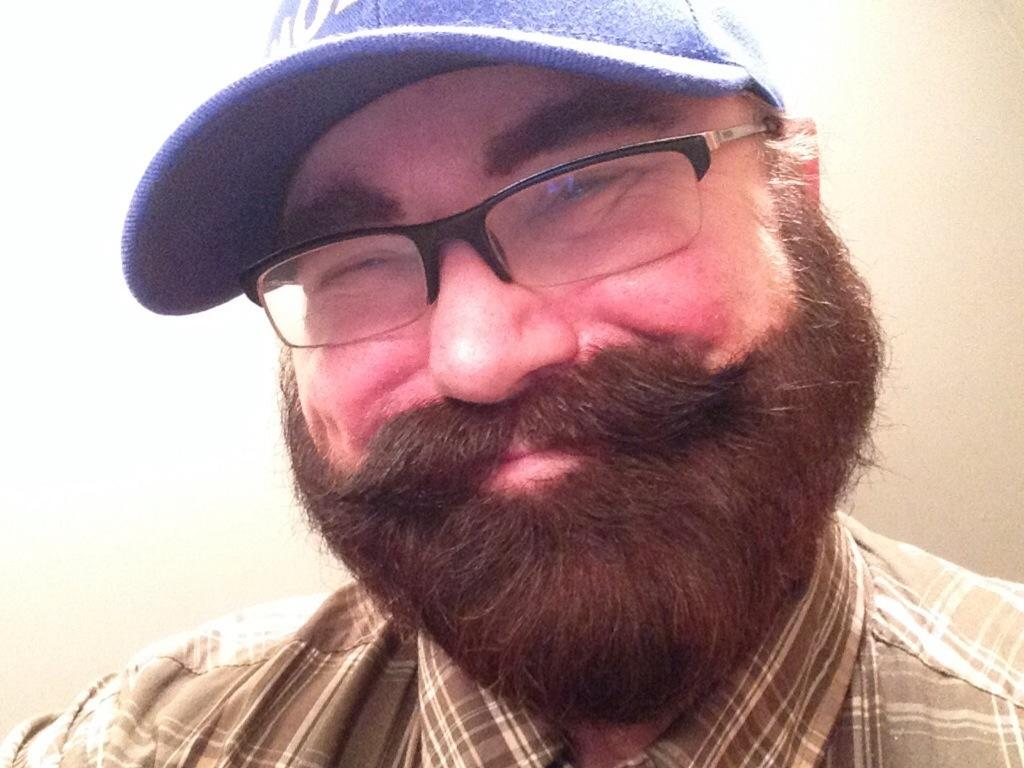Who is the main subject in the image? There is a person in the center of the image. What is the person wearing on their head? The person is wearing a cap. What type of eyewear is the person wearing? The person is wearing spectacles. What can be seen in the background of the image? There is a wall in the background of the image. What type of shoe is the person wearing in the image? There is no information about the person's footwear in the image, so we cannot determine the type of shoe they are wearing. 